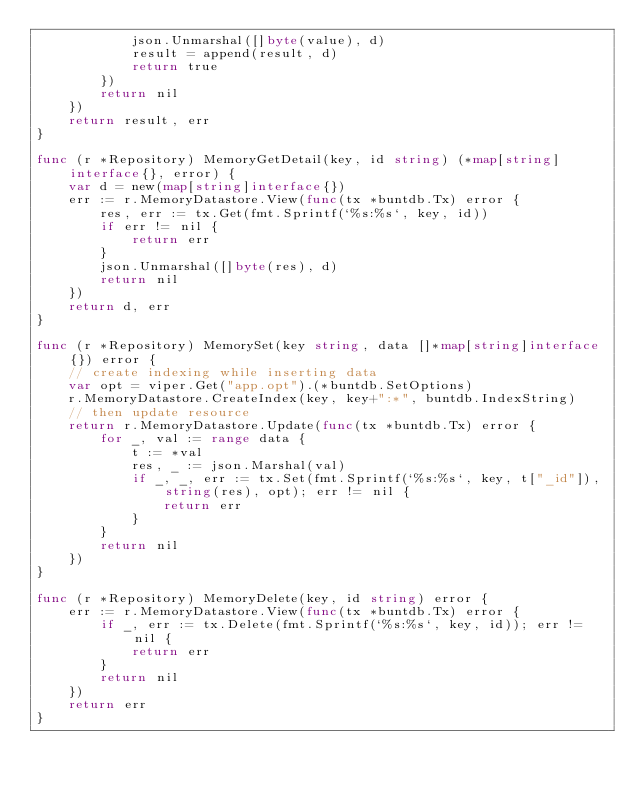Convert code to text. <code><loc_0><loc_0><loc_500><loc_500><_Go_>			json.Unmarshal([]byte(value), d)
			result = append(result, d)
			return true
		})
		return nil
	})
	return result, err
}

func (r *Repository) MemoryGetDetail(key, id string) (*map[string]interface{}, error) {
	var d = new(map[string]interface{})
	err := r.MemoryDatastore.View(func(tx *buntdb.Tx) error {
		res, err := tx.Get(fmt.Sprintf(`%s:%s`, key, id))
		if err != nil {
			return err
		}
		json.Unmarshal([]byte(res), d)
		return nil
	})
	return d, err
}

func (r *Repository) MemorySet(key string, data []*map[string]interface{}) error {
	// create indexing while inserting data
	var opt = viper.Get("app.opt").(*buntdb.SetOptions)
	r.MemoryDatastore.CreateIndex(key, key+":*", buntdb.IndexString)
	// then update resource
	return r.MemoryDatastore.Update(func(tx *buntdb.Tx) error {
		for _, val := range data {
			t := *val
			res, _ := json.Marshal(val)
			if _, _, err := tx.Set(fmt.Sprintf(`%s:%s`, key, t["_id"]), string(res), opt); err != nil {
				return err
			}
		}
		return nil
	})
}

func (r *Repository) MemoryDelete(key, id string) error {
	err := r.MemoryDatastore.View(func(tx *buntdb.Tx) error {
		if _, err := tx.Delete(fmt.Sprintf(`%s:%s`, key, id)); err != nil {
			return err
		}
		return nil
	})
	return err
}
</code> 